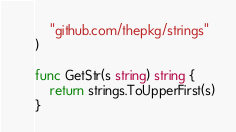<code> <loc_0><loc_0><loc_500><loc_500><_Go_>	"github.com/thepkg/strings"
)

func GetStr(s string) string {
	return strings.ToUpperFirst(s)
}
</code> 